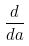Convert formula to latex. <formula><loc_0><loc_0><loc_500><loc_500>\frac { d } { d a }</formula> 